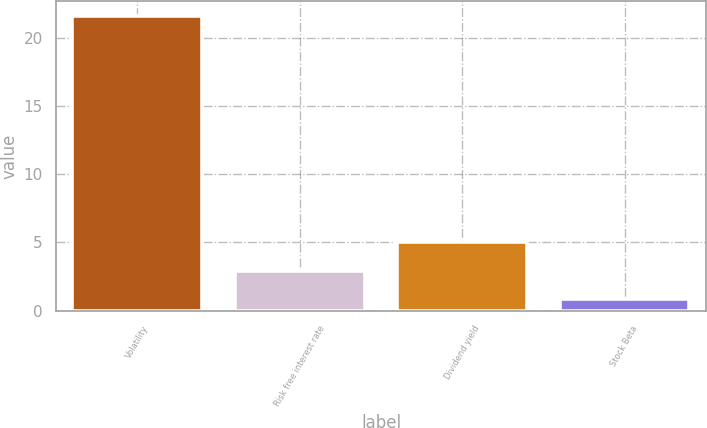<chart> <loc_0><loc_0><loc_500><loc_500><bar_chart><fcel>Volatility<fcel>Risk free interest rate<fcel>Dividend yield<fcel>Stock Beta<nl><fcel>21.6<fcel>2.92<fcel>5<fcel>0.84<nl></chart> 